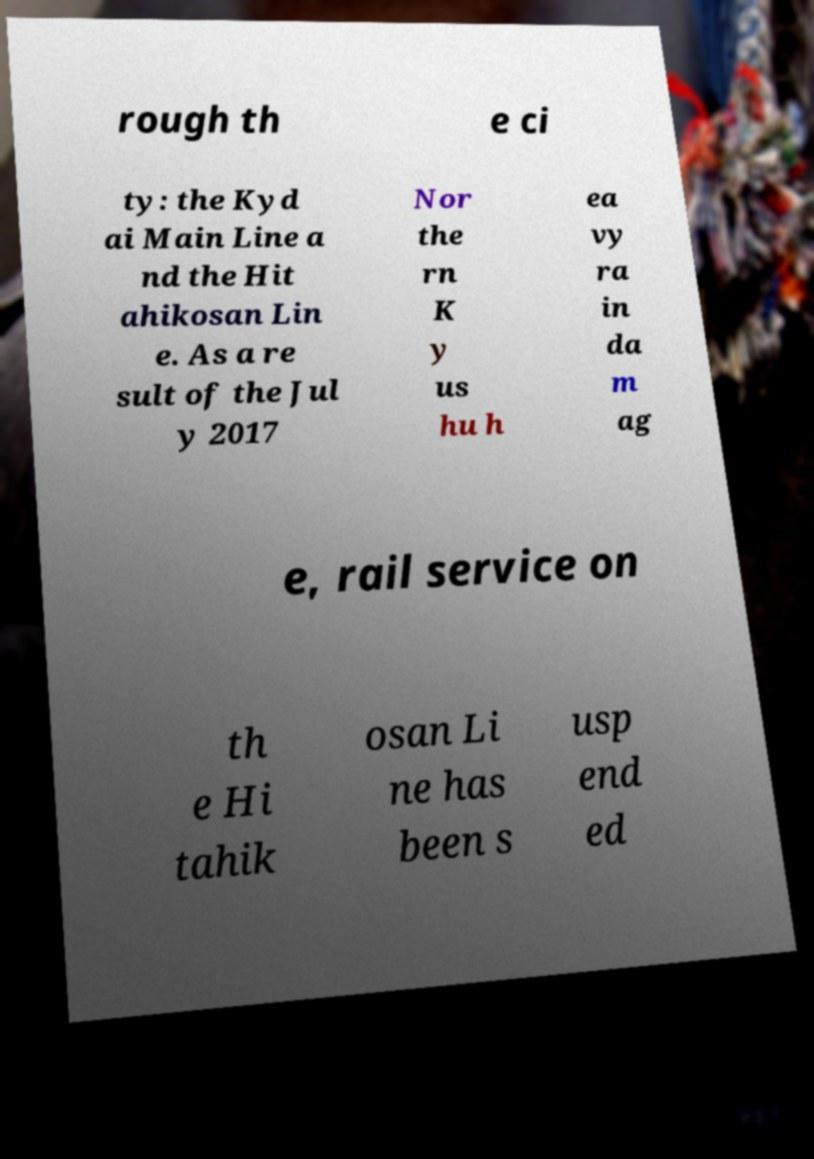What messages or text are displayed in this image? I need them in a readable, typed format. rough th e ci ty: the Kyd ai Main Line a nd the Hit ahikosan Lin e. As a re sult of the Jul y 2017 Nor the rn K y us hu h ea vy ra in da m ag e, rail service on th e Hi tahik osan Li ne has been s usp end ed 